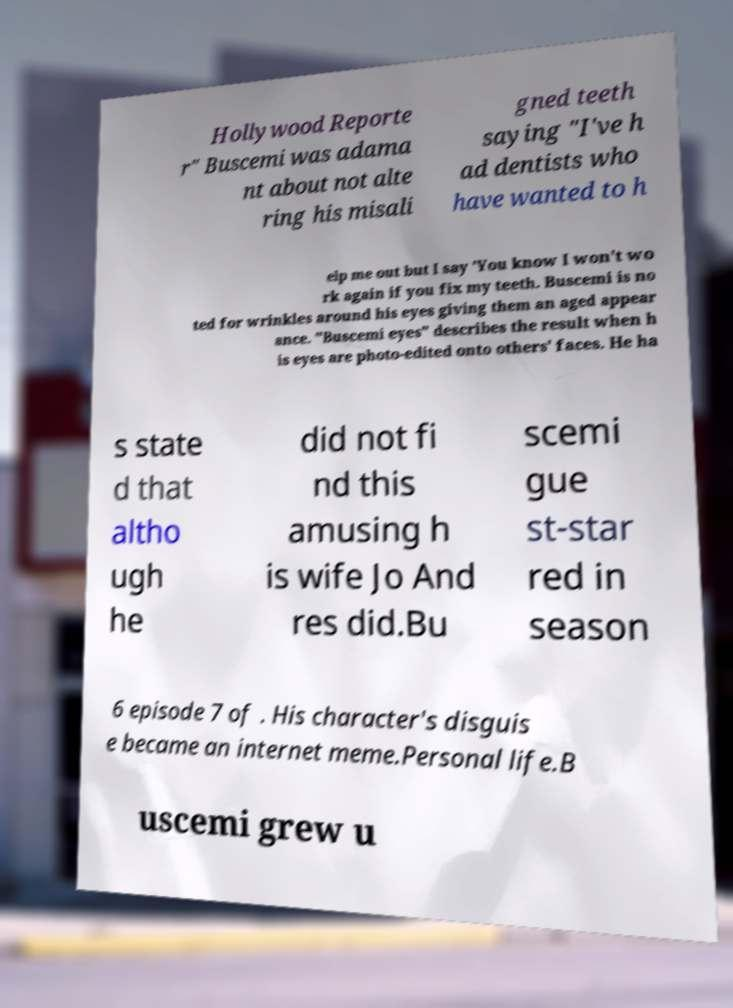There's text embedded in this image that I need extracted. Can you transcribe it verbatim? Hollywood Reporte r" Buscemi was adama nt about not alte ring his misali gned teeth saying "I've h ad dentists who have wanted to h elp me out but I say 'You know I won't wo rk again if you fix my teeth. Buscemi is no ted for wrinkles around his eyes giving them an aged appear ance. "Buscemi eyes" describes the result when h is eyes are photo-edited onto others' faces. He ha s state d that altho ugh he did not fi nd this amusing h is wife Jo And res did.Bu scemi gue st-star red in season 6 episode 7 of . His character's disguis e became an internet meme.Personal life.B uscemi grew u 